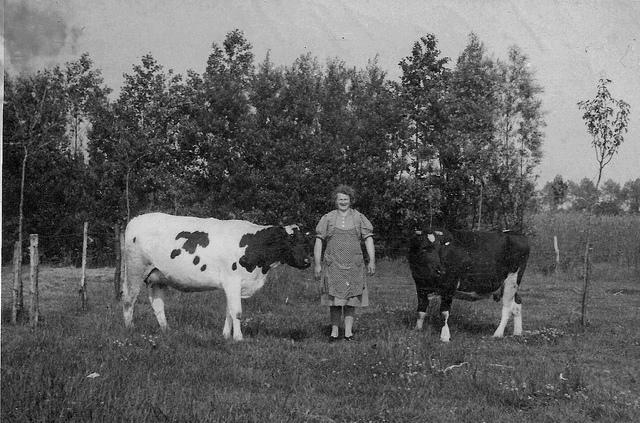What is the woman's orientation in relation to the cows? Please explain your reasoning. in between. There is a cow on each side of her 